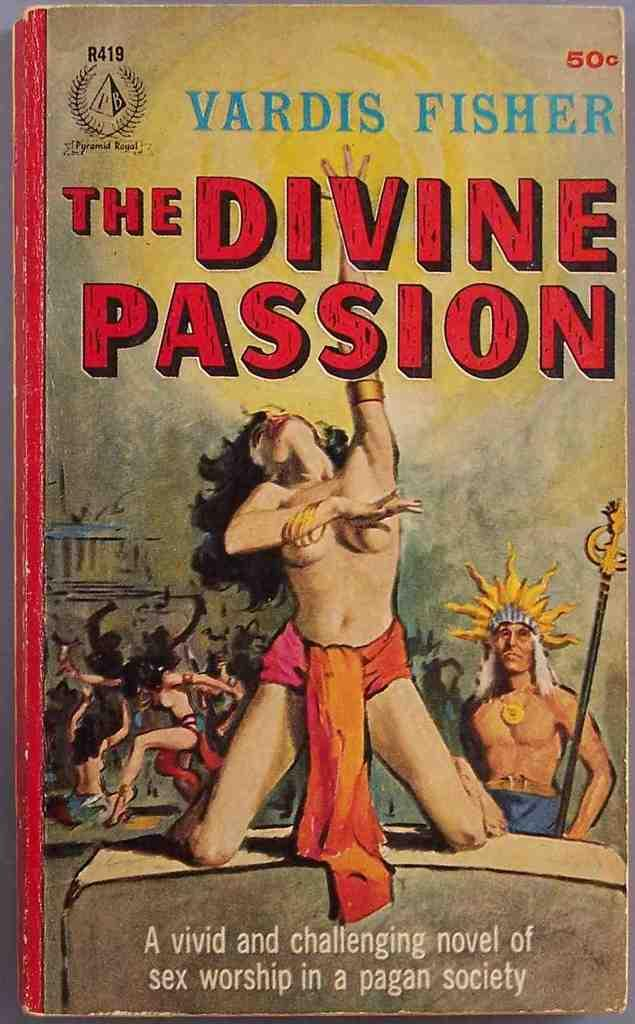What is the main subject of the image? The main subject of the image is a photograph of a story book. What can be read on the book's cover? The title "The divine passion" is written on the book's cover. What is the woman on the book cover doing? The woman on the book cover is sitting on her knees. Is the queen sitting on her throne on the book cover? There is no queen or throne present on the book cover; it features a woman sitting on her knees. 